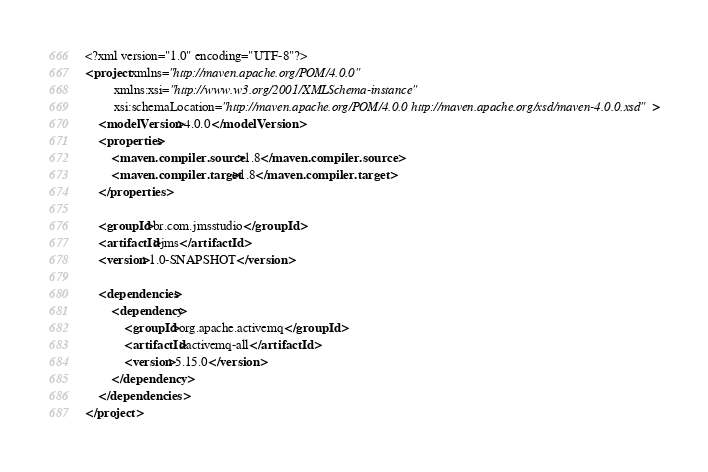<code> <loc_0><loc_0><loc_500><loc_500><_XML_><?xml version="1.0" encoding="UTF-8"?>
<project xmlns="http://maven.apache.org/POM/4.0.0"
         xmlns:xsi="http://www.w3.org/2001/XMLSchema-instance"
         xsi:schemaLocation="http://maven.apache.org/POM/4.0.0 http://maven.apache.org/xsd/maven-4.0.0.xsd">
    <modelVersion>4.0.0</modelVersion>
    <properties>
        <maven.compiler.source>1.8</maven.compiler.source>
        <maven.compiler.target>1.8</maven.compiler.target>
    </properties>

    <groupId>br.com.jmsstudio</groupId>
    <artifactId>jms</artifactId>
    <version>1.0-SNAPSHOT</version>

    <dependencies>
        <dependency>
            <groupId>org.apache.activemq</groupId>
            <artifactId>activemq-all</artifactId>
            <version>5.15.0</version>
        </dependency>
    </dependencies>
</project></code> 